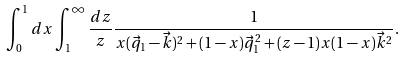Convert formula to latex. <formula><loc_0><loc_0><loc_500><loc_500>\int _ { 0 } ^ { 1 } d x \int _ { 1 } ^ { \infty } \frac { d z } { z } \frac { 1 } { x ( \vec { q } _ { 1 } - \vec { k } ) ^ { 2 } + ( 1 - x ) \vec { q } _ { 1 } ^ { 2 } + ( z - 1 ) x ( 1 - x ) \vec { k } ^ { 2 } } .</formula> 